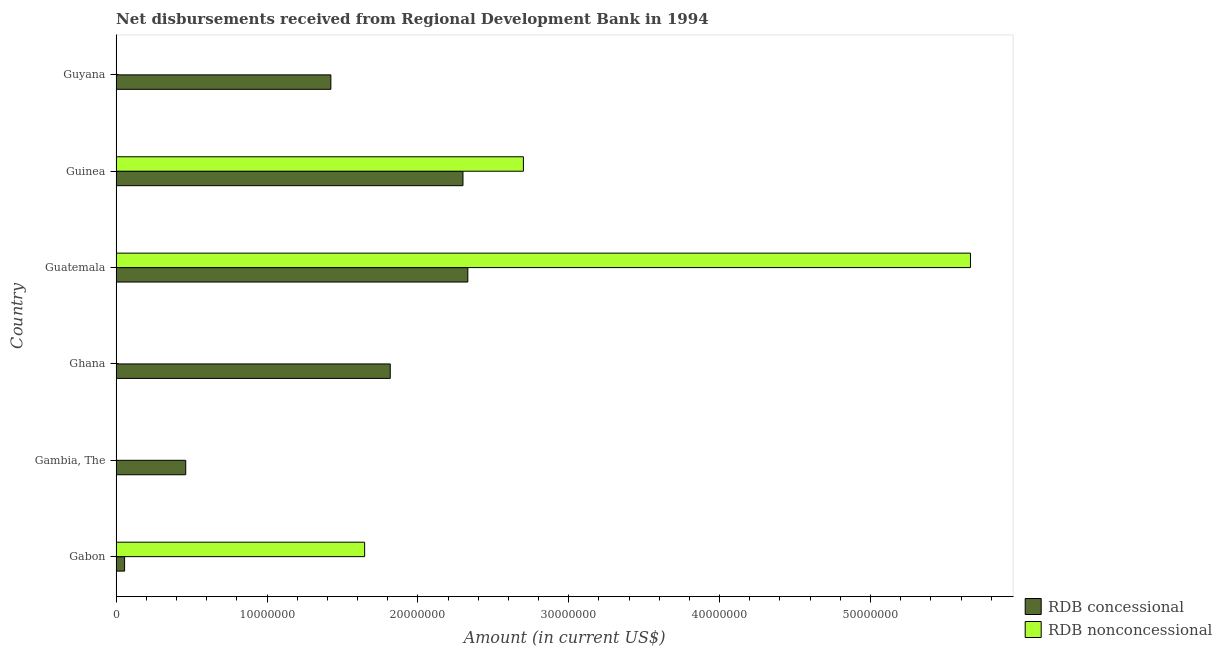How many different coloured bars are there?
Give a very brief answer. 2. How many bars are there on the 2nd tick from the bottom?
Provide a succinct answer. 1. What is the label of the 2nd group of bars from the top?
Ensure brevity in your answer.  Guinea. In how many cases, is the number of bars for a given country not equal to the number of legend labels?
Make the answer very short. 3. What is the net non concessional disbursements from rdb in Guinea?
Keep it short and to the point. 2.70e+07. Across all countries, what is the maximum net concessional disbursements from rdb?
Provide a short and direct response. 2.33e+07. Across all countries, what is the minimum net non concessional disbursements from rdb?
Your response must be concise. 0. In which country was the net concessional disbursements from rdb maximum?
Your answer should be very brief. Guatemala. What is the total net concessional disbursements from rdb in the graph?
Offer a terse response. 8.39e+07. What is the difference between the net concessional disbursements from rdb in Guatemala and that in Guinea?
Your answer should be very brief. 3.22e+05. What is the difference between the net non concessional disbursements from rdb in Gambia, The and the net concessional disbursements from rdb in Gabon?
Give a very brief answer. -5.61e+05. What is the average net concessional disbursements from rdb per country?
Provide a short and direct response. 1.40e+07. What is the difference between the net concessional disbursements from rdb and net non concessional disbursements from rdb in Guatemala?
Offer a very short reply. -3.33e+07. What is the ratio of the net concessional disbursements from rdb in Ghana to that in Guyana?
Provide a succinct answer. 1.28. Is the net concessional disbursements from rdb in Gambia, The less than that in Ghana?
Your response must be concise. Yes. What is the difference between the highest and the second highest net concessional disbursements from rdb?
Offer a terse response. 3.22e+05. What is the difference between the highest and the lowest net non concessional disbursements from rdb?
Your answer should be compact. 5.66e+07. In how many countries, is the net non concessional disbursements from rdb greater than the average net non concessional disbursements from rdb taken over all countries?
Your response must be concise. 2. How many countries are there in the graph?
Your answer should be very brief. 6. What is the difference between two consecutive major ticks on the X-axis?
Provide a short and direct response. 1.00e+07. Are the values on the major ticks of X-axis written in scientific E-notation?
Provide a succinct answer. No. Does the graph contain any zero values?
Provide a succinct answer. Yes. Does the graph contain grids?
Make the answer very short. No. How are the legend labels stacked?
Offer a very short reply. Vertical. What is the title of the graph?
Provide a short and direct response. Net disbursements received from Regional Development Bank in 1994. Does "Age 15+" appear as one of the legend labels in the graph?
Ensure brevity in your answer.  No. What is the Amount (in current US$) of RDB concessional in Gabon?
Your response must be concise. 5.61e+05. What is the Amount (in current US$) of RDB nonconcessional in Gabon?
Provide a short and direct response. 1.65e+07. What is the Amount (in current US$) in RDB concessional in Gambia, The?
Make the answer very short. 4.61e+06. What is the Amount (in current US$) in RDB nonconcessional in Gambia, The?
Offer a very short reply. 0. What is the Amount (in current US$) in RDB concessional in Ghana?
Give a very brief answer. 1.82e+07. What is the Amount (in current US$) in RDB concessional in Guatemala?
Give a very brief answer. 2.33e+07. What is the Amount (in current US$) of RDB nonconcessional in Guatemala?
Your answer should be compact. 5.66e+07. What is the Amount (in current US$) of RDB concessional in Guinea?
Make the answer very short. 2.30e+07. What is the Amount (in current US$) in RDB nonconcessional in Guinea?
Ensure brevity in your answer.  2.70e+07. What is the Amount (in current US$) of RDB concessional in Guyana?
Make the answer very short. 1.42e+07. What is the Amount (in current US$) of RDB nonconcessional in Guyana?
Keep it short and to the point. 0. Across all countries, what is the maximum Amount (in current US$) of RDB concessional?
Provide a short and direct response. 2.33e+07. Across all countries, what is the maximum Amount (in current US$) of RDB nonconcessional?
Provide a succinct answer. 5.66e+07. Across all countries, what is the minimum Amount (in current US$) in RDB concessional?
Ensure brevity in your answer.  5.61e+05. What is the total Amount (in current US$) in RDB concessional in the graph?
Offer a very short reply. 8.39e+07. What is the total Amount (in current US$) of RDB nonconcessional in the graph?
Provide a short and direct response. 1.00e+08. What is the difference between the Amount (in current US$) of RDB concessional in Gabon and that in Gambia, The?
Give a very brief answer. -4.05e+06. What is the difference between the Amount (in current US$) of RDB concessional in Gabon and that in Ghana?
Your response must be concise. -1.76e+07. What is the difference between the Amount (in current US$) in RDB concessional in Gabon and that in Guatemala?
Your answer should be compact. -2.28e+07. What is the difference between the Amount (in current US$) of RDB nonconcessional in Gabon and that in Guatemala?
Ensure brevity in your answer.  -4.02e+07. What is the difference between the Amount (in current US$) of RDB concessional in Gabon and that in Guinea?
Offer a very short reply. -2.24e+07. What is the difference between the Amount (in current US$) of RDB nonconcessional in Gabon and that in Guinea?
Keep it short and to the point. -1.05e+07. What is the difference between the Amount (in current US$) of RDB concessional in Gabon and that in Guyana?
Ensure brevity in your answer.  -1.37e+07. What is the difference between the Amount (in current US$) of RDB concessional in Gambia, The and that in Ghana?
Your answer should be compact. -1.36e+07. What is the difference between the Amount (in current US$) in RDB concessional in Gambia, The and that in Guatemala?
Offer a very short reply. -1.87e+07. What is the difference between the Amount (in current US$) of RDB concessional in Gambia, The and that in Guinea?
Your answer should be compact. -1.84e+07. What is the difference between the Amount (in current US$) of RDB concessional in Gambia, The and that in Guyana?
Make the answer very short. -9.62e+06. What is the difference between the Amount (in current US$) in RDB concessional in Ghana and that in Guatemala?
Offer a terse response. -5.14e+06. What is the difference between the Amount (in current US$) of RDB concessional in Ghana and that in Guinea?
Make the answer very short. -4.82e+06. What is the difference between the Amount (in current US$) in RDB concessional in Ghana and that in Guyana?
Offer a very short reply. 3.94e+06. What is the difference between the Amount (in current US$) in RDB concessional in Guatemala and that in Guinea?
Your answer should be very brief. 3.22e+05. What is the difference between the Amount (in current US$) of RDB nonconcessional in Guatemala and that in Guinea?
Ensure brevity in your answer.  2.96e+07. What is the difference between the Amount (in current US$) in RDB concessional in Guatemala and that in Guyana?
Make the answer very short. 9.08e+06. What is the difference between the Amount (in current US$) in RDB concessional in Guinea and that in Guyana?
Your answer should be very brief. 8.76e+06. What is the difference between the Amount (in current US$) in RDB concessional in Gabon and the Amount (in current US$) in RDB nonconcessional in Guatemala?
Offer a very short reply. -5.61e+07. What is the difference between the Amount (in current US$) in RDB concessional in Gabon and the Amount (in current US$) in RDB nonconcessional in Guinea?
Provide a short and direct response. -2.64e+07. What is the difference between the Amount (in current US$) in RDB concessional in Gambia, The and the Amount (in current US$) in RDB nonconcessional in Guatemala?
Provide a succinct answer. -5.20e+07. What is the difference between the Amount (in current US$) in RDB concessional in Gambia, The and the Amount (in current US$) in RDB nonconcessional in Guinea?
Offer a very short reply. -2.24e+07. What is the difference between the Amount (in current US$) of RDB concessional in Ghana and the Amount (in current US$) of RDB nonconcessional in Guatemala?
Your answer should be compact. -3.85e+07. What is the difference between the Amount (in current US$) in RDB concessional in Ghana and the Amount (in current US$) in RDB nonconcessional in Guinea?
Offer a very short reply. -8.83e+06. What is the difference between the Amount (in current US$) in RDB concessional in Guatemala and the Amount (in current US$) in RDB nonconcessional in Guinea?
Keep it short and to the point. -3.68e+06. What is the average Amount (in current US$) of RDB concessional per country?
Give a very brief answer. 1.40e+07. What is the average Amount (in current US$) in RDB nonconcessional per country?
Offer a terse response. 1.67e+07. What is the difference between the Amount (in current US$) in RDB concessional and Amount (in current US$) in RDB nonconcessional in Gabon?
Ensure brevity in your answer.  -1.59e+07. What is the difference between the Amount (in current US$) of RDB concessional and Amount (in current US$) of RDB nonconcessional in Guatemala?
Provide a succinct answer. -3.33e+07. What is the difference between the Amount (in current US$) of RDB concessional and Amount (in current US$) of RDB nonconcessional in Guinea?
Offer a terse response. -4.01e+06. What is the ratio of the Amount (in current US$) of RDB concessional in Gabon to that in Gambia, The?
Provide a succinct answer. 0.12. What is the ratio of the Amount (in current US$) of RDB concessional in Gabon to that in Ghana?
Your response must be concise. 0.03. What is the ratio of the Amount (in current US$) in RDB concessional in Gabon to that in Guatemala?
Keep it short and to the point. 0.02. What is the ratio of the Amount (in current US$) in RDB nonconcessional in Gabon to that in Guatemala?
Give a very brief answer. 0.29. What is the ratio of the Amount (in current US$) in RDB concessional in Gabon to that in Guinea?
Offer a terse response. 0.02. What is the ratio of the Amount (in current US$) in RDB nonconcessional in Gabon to that in Guinea?
Provide a succinct answer. 0.61. What is the ratio of the Amount (in current US$) of RDB concessional in Gabon to that in Guyana?
Offer a terse response. 0.04. What is the ratio of the Amount (in current US$) in RDB concessional in Gambia, The to that in Ghana?
Your answer should be very brief. 0.25. What is the ratio of the Amount (in current US$) of RDB concessional in Gambia, The to that in Guatemala?
Your answer should be compact. 0.2. What is the ratio of the Amount (in current US$) of RDB concessional in Gambia, The to that in Guinea?
Your response must be concise. 0.2. What is the ratio of the Amount (in current US$) in RDB concessional in Gambia, The to that in Guyana?
Keep it short and to the point. 0.32. What is the ratio of the Amount (in current US$) of RDB concessional in Ghana to that in Guatemala?
Your answer should be very brief. 0.78. What is the ratio of the Amount (in current US$) in RDB concessional in Ghana to that in Guinea?
Keep it short and to the point. 0.79. What is the ratio of the Amount (in current US$) of RDB concessional in Ghana to that in Guyana?
Ensure brevity in your answer.  1.28. What is the ratio of the Amount (in current US$) in RDB concessional in Guatemala to that in Guinea?
Provide a short and direct response. 1.01. What is the ratio of the Amount (in current US$) of RDB nonconcessional in Guatemala to that in Guinea?
Make the answer very short. 2.1. What is the ratio of the Amount (in current US$) in RDB concessional in Guatemala to that in Guyana?
Give a very brief answer. 1.64. What is the ratio of the Amount (in current US$) in RDB concessional in Guinea to that in Guyana?
Provide a succinct answer. 1.62. What is the difference between the highest and the second highest Amount (in current US$) of RDB concessional?
Provide a succinct answer. 3.22e+05. What is the difference between the highest and the second highest Amount (in current US$) of RDB nonconcessional?
Your response must be concise. 2.96e+07. What is the difference between the highest and the lowest Amount (in current US$) of RDB concessional?
Ensure brevity in your answer.  2.28e+07. What is the difference between the highest and the lowest Amount (in current US$) of RDB nonconcessional?
Offer a terse response. 5.66e+07. 